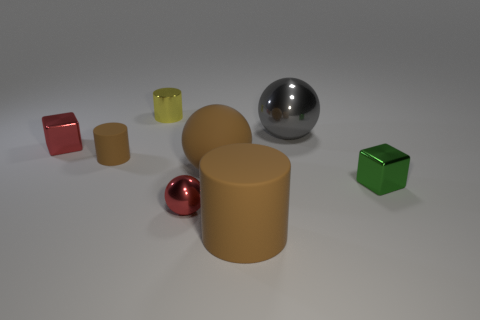Add 2 large brown things. How many objects exist? 10 Subtract all cylinders. How many objects are left? 5 Subtract 0 yellow blocks. How many objects are left? 8 Subtract all tiny brown cylinders. Subtract all small red spheres. How many objects are left? 6 Add 7 red things. How many red things are left? 9 Add 4 big purple shiny spheres. How many big purple shiny spheres exist? 4 